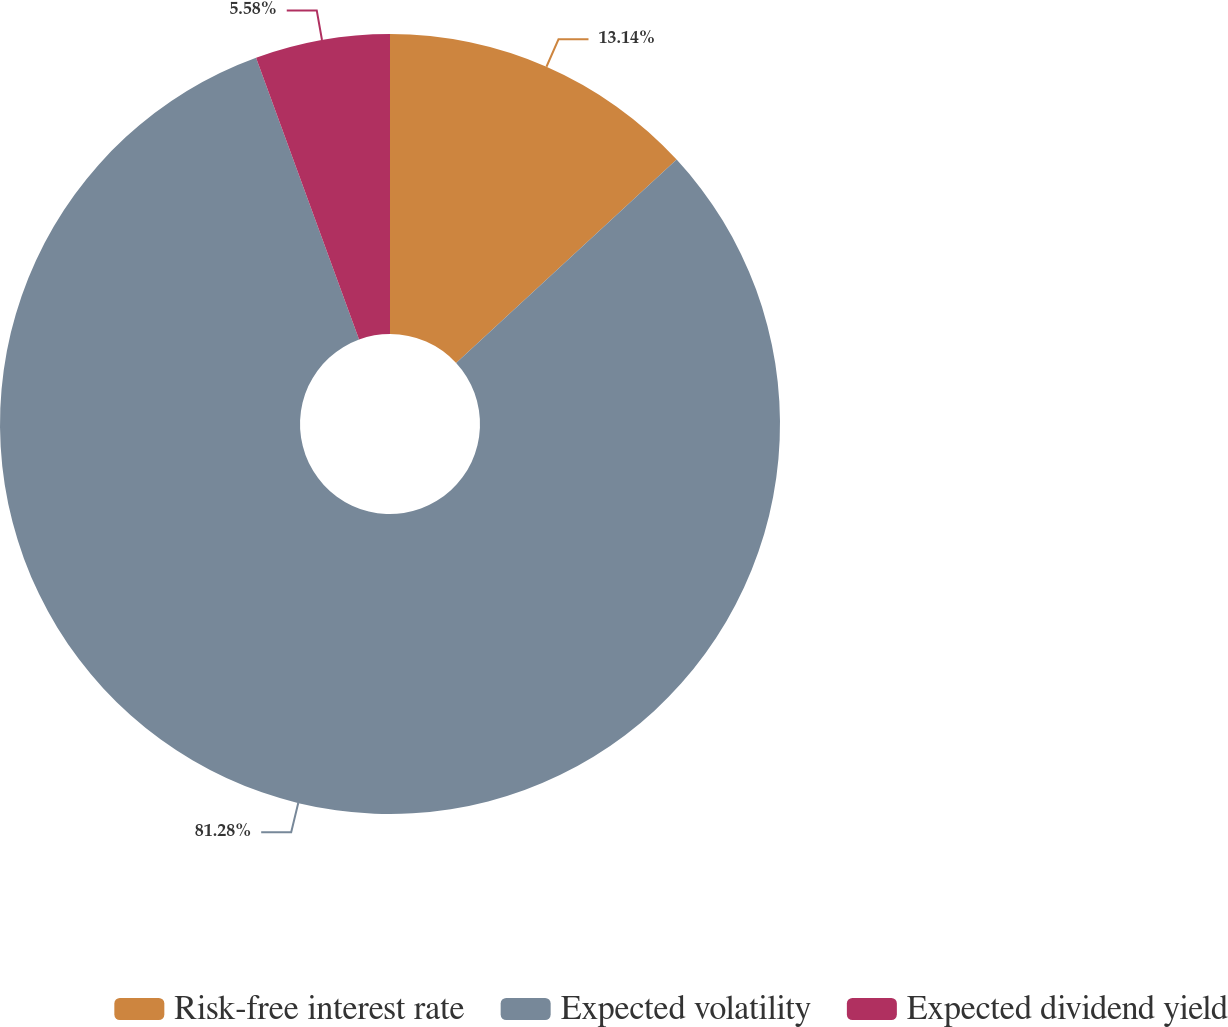Convert chart. <chart><loc_0><loc_0><loc_500><loc_500><pie_chart><fcel>Risk-free interest rate<fcel>Expected volatility<fcel>Expected dividend yield<nl><fcel>13.14%<fcel>81.28%<fcel>5.58%<nl></chart> 